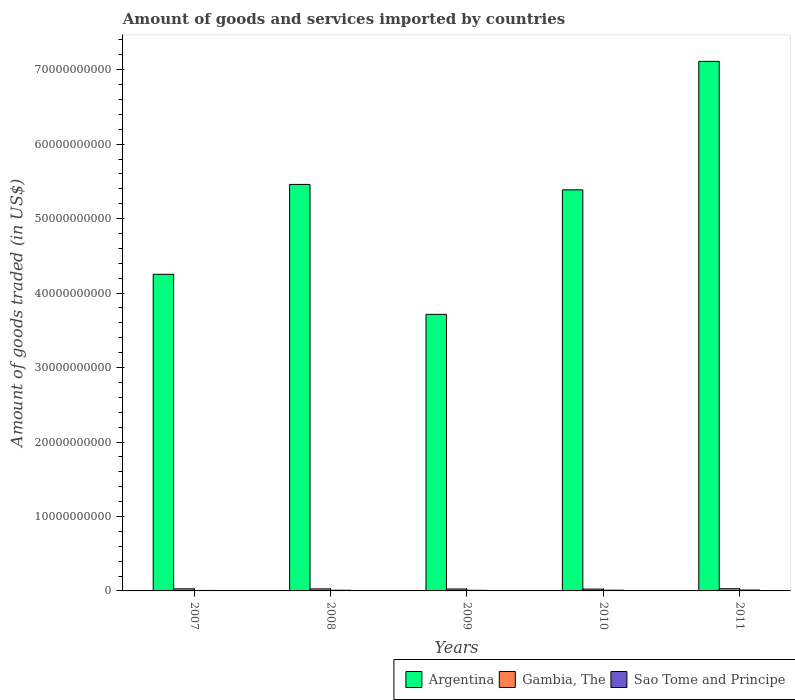How many groups of bars are there?
Your answer should be very brief. 5. How many bars are there on the 3rd tick from the right?
Your response must be concise. 3. What is the label of the 5th group of bars from the left?
Provide a short and direct response. 2011. In how many cases, is the number of bars for a given year not equal to the number of legend labels?
Ensure brevity in your answer.  0. What is the total amount of goods and services imported in Sao Tome and Principe in 2011?
Your answer should be very brief. 1.16e+08. Across all years, what is the maximum total amount of goods and services imported in Sao Tome and Principe?
Offer a terse response. 1.16e+08. Across all years, what is the minimum total amount of goods and services imported in Argentina?
Your answer should be compact. 3.71e+1. In which year was the total amount of goods and services imported in Argentina maximum?
Ensure brevity in your answer.  2011. What is the total total amount of goods and services imported in Sao Tome and Principe in the graph?
Offer a very short reply. 4.53e+08. What is the difference between the total amount of goods and services imported in Sao Tome and Principe in 2007 and that in 2009?
Make the answer very short. -1.89e+07. What is the difference between the total amount of goods and services imported in Gambia, The in 2008 and the total amount of goods and services imported in Argentina in 2007?
Offer a terse response. -4.22e+1. What is the average total amount of goods and services imported in Gambia, The per year?
Provide a succinct answer. 2.71e+08. In the year 2008, what is the difference between the total amount of goods and services imported in Argentina and total amount of goods and services imported in Gambia, The?
Your response must be concise. 5.43e+1. In how many years, is the total amount of goods and services imported in Argentina greater than 40000000000 US$?
Make the answer very short. 4. What is the ratio of the total amount of goods and services imported in Gambia, The in 2008 to that in 2009?
Make the answer very short. 1.06. Is the difference between the total amount of goods and services imported in Argentina in 2008 and 2010 greater than the difference between the total amount of goods and services imported in Gambia, The in 2008 and 2010?
Provide a succinct answer. Yes. What is the difference between the highest and the second highest total amount of goods and services imported in Gambia, The?
Ensure brevity in your answer.  1.60e+07. What is the difference between the highest and the lowest total amount of goods and services imported in Gambia, The?
Provide a short and direct response. 4.98e+07. What does the 2nd bar from the left in 2007 represents?
Offer a very short reply. Gambia, The. What does the 2nd bar from the right in 2008 represents?
Provide a succinct answer. Gambia, The. How many years are there in the graph?
Make the answer very short. 5. What is the difference between two consecutive major ticks on the Y-axis?
Give a very brief answer. 1.00e+1. Are the values on the major ticks of Y-axis written in scientific E-notation?
Give a very brief answer. No. Does the graph contain grids?
Make the answer very short. No. Where does the legend appear in the graph?
Offer a terse response. Bottom right. How many legend labels are there?
Your answer should be compact. 3. How are the legend labels stacked?
Offer a terse response. Horizontal. What is the title of the graph?
Make the answer very short. Amount of goods and services imported by countries. What is the label or title of the X-axis?
Your answer should be very brief. Years. What is the label or title of the Y-axis?
Your response must be concise. Amount of goods traded (in US$). What is the Amount of goods traded (in US$) in Argentina in 2007?
Make the answer very short. 4.25e+1. What is the Amount of goods traded (in US$) of Gambia, The in 2007?
Your response must be concise. 2.80e+08. What is the Amount of goods traded (in US$) of Sao Tome and Principe in 2007?
Your answer should be very brief. 6.49e+07. What is the Amount of goods traded (in US$) of Argentina in 2008?
Provide a short and direct response. 5.46e+1. What is the Amount of goods traded (in US$) in Gambia, The in 2008?
Provide a short and direct response. 2.75e+08. What is the Amount of goods traded (in US$) in Sao Tome and Principe in 2008?
Your response must be concise. 9.22e+07. What is the Amount of goods traded (in US$) in Argentina in 2009?
Offer a very short reply. 3.71e+1. What is the Amount of goods traded (in US$) of Gambia, The in 2009?
Provide a short and direct response. 2.60e+08. What is the Amount of goods traded (in US$) in Sao Tome and Principe in 2009?
Your answer should be compact. 8.38e+07. What is the Amount of goods traded (in US$) of Argentina in 2010?
Give a very brief answer. 5.39e+1. What is the Amount of goods traded (in US$) of Gambia, The in 2010?
Keep it short and to the point. 2.46e+08. What is the Amount of goods traded (in US$) of Sao Tome and Principe in 2010?
Ensure brevity in your answer.  9.62e+07. What is the Amount of goods traded (in US$) in Argentina in 2011?
Make the answer very short. 7.11e+1. What is the Amount of goods traded (in US$) of Gambia, The in 2011?
Offer a terse response. 2.96e+08. What is the Amount of goods traded (in US$) in Sao Tome and Principe in 2011?
Your answer should be very brief. 1.16e+08. Across all years, what is the maximum Amount of goods traded (in US$) of Argentina?
Provide a short and direct response. 7.11e+1. Across all years, what is the maximum Amount of goods traded (in US$) of Gambia, The?
Provide a succinct answer. 2.96e+08. Across all years, what is the maximum Amount of goods traded (in US$) of Sao Tome and Principe?
Provide a short and direct response. 1.16e+08. Across all years, what is the minimum Amount of goods traded (in US$) in Argentina?
Make the answer very short. 3.71e+1. Across all years, what is the minimum Amount of goods traded (in US$) in Gambia, The?
Offer a terse response. 2.46e+08. Across all years, what is the minimum Amount of goods traded (in US$) in Sao Tome and Principe?
Provide a short and direct response. 6.49e+07. What is the total Amount of goods traded (in US$) of Argentina in the graph?
Keep it short and to the point. 2.59e+11. What is the total Amount of goods traded (in US$) in Gambia, The in the graph?
Your response must be concise. 1.36e+09. What is the total Amount of goods traded (in US$) in Sao Tome and Principe in the graph?
Provide a succinct answer. 4.53e+08. What is the difference between the Amount of goods traded (in US$) of Argentina in 2007 and that in 2008?
Provide a succinct answer. -1.21e+1. What is the difference between the Amount of goods traded (in US$) of Gambia, The in 2007 and that in 2008?
Keep it short and to the point. 5.01e+06. What is the difference between the Amount of goods traded (in US$) in Sao Tome and Principe in 2007 and that in 2008?
Your answer should be very brief. -2.73e+07. What is the difference between the Amount of goods traded (in US$) in Argentina in 2007 and that in 2009?
Offer a terse response. 5.38e+09. What is the difference between the Amount of goods traded (in US$) in Gambia, The in 2007 and that in 2009?
Provide a succinct answer. 1.96e+07. What is the difference between the Amount of goods traded (in US$) of Sao Tome and Principe in 2007 and that in 2009?
Give a very brief answer. -1.89e+07. What is the difference between the Amount of goods traded (in US$) in Argentina in 2007 and that in 2010?
Keep it short and to the point. -1.13e+1. What is the difference between the Amount of goods traded (in US$) of Gambia, The in 2007 and that in 2010?
Provide a short and direct response. 3.38e+07. What is the difference between the Amount of goods traded (in US$) in Sao Tome and Principe in 2007 and that in 2010?
Your answer should be very brief. -3.13e+07. What is the difference between the Amount of goods traded (in US$) in Argentina in 2007 and that in 2011?
Provide a short and direct response. -2.86e+1. What is the difference between the Amount of goods traded (in US$) in Gambia, The in 2007 and that in 2011?
Your answer should be compact. -1.60e+07. What is the difference between the Amount of goods traded (in US$) of Sao Tome and Principe in 2007 and that in 2011?
Your answer should be very brief. -5.08e+07. What is the difference between the Amount of goods traded (in US$) of Argentina in 2008 and that in 2009?
Your answer should be compact. 1.75e+1. What is the difference between the Amount of goods traded (in US$) of Gambia, The in 2008 and that in 2009?
Ensure brevity in your answer.  1.46e+07. What is the difference between the Amount of goods traded (in US$) in Sao Tome and Principe in 2008 and that in 2009?
Keep it short and to the point. 8.39e+06. What is the difference between the Amount of goods traded (in US$) in Argentina in 2008 and that in 2010?
Offer a terse response. 7.28e+08. What is the difference between the Amount of goods traded (in US$) of Gambia, The in 2008 and that in 2010?
Keep it short and to the point. 2.88e+07. What is the difference between the Amount of goods traded (in US$) of Sao Tome and Principe in 2008 and that in 2010?
Your answer should be very brief. -4.04e+06. What is the difference between the Amount of goods traded (in US$) in Argentina in 2008 and that in 2011?
Make the answer very short. -1.65e+1. What is the difference between the Amount of goods traded (in US$) in Gambia, The in 2008 and that in 2011?
Ensure brevity in your answer.  -2.10e+07. What is the difference between the Amount of goods traded (in US$) of Sao Tome and Principe in 2008 and that in 2011?
Make the answer very short. -2.35e+07. What is the difference between the Amount of goods traded (in US$) in Argentina in 2009 and that in 2010?
Give a very brief answer. -1.67e+1. What is the difference between the Amount of goods traded (in US$) in Gambia, The in 2009 and that in 2010?
Your answer should be compact. 1.42e+07. What is the difference between the Amount of goods traded (in US$) in Sao Tome and Principe in 2009 and that in 2010?
Your answer should be compact. -1.24e+07. What is the difference between the Amount of goods traded (in US$) in Argentina in 2009 and that in 2011?
Your response must be concise. -3.40e+1. What is the difference between the Amount of goods traded (in US$) in Gambia, The in 2009 and that in 2011?
Make the answer very short. -3.56e+07. What is the difference between the Amount of goods traded (in US$) of Sao Tome and Principe in 2009 and that in 2011?
Your answer should be very brief. -3.19e+07. What is the difference between the Amount of goods traded (in US$) in Argentina in 2010 and that in 2011?
Make the answer very short. -1.73e+1. What is the difference between the Amount of goods traded (in US$) of Gambia, The in 2010 and that in 2011?
Give a very brief answer. -4.98e+07. What is the difference between the Amount of goods traded (in US$) in Sao Tome and Principe in 2010 and that in 2011?
Your answer should be compact. -1.95e+07. What is the difference between the Amount of goods traded (in US$) of Argentina in 2007 and the Amount of goods traded (in US$) of Gambia, The in 2008?
Offer a very short reply. 4.22e+1. What is the difference between the Amount of goods traded (in US$) of Argentina in 2007 and the Amount of goods traded (in US$) of Sao Tome and Principe in 2008?
Keep it short and to the point. 4.24e+1. What is the difference between the Amount of goods traded (in US$) in Gambia, The in 2007 and the Amount of goods traded (in US$) in Sao Tome and Principe in 2008?
Your answer should be very brief. 1.87e+08. What is the difference between the Amount of goods traded (in US$) in Argentina in 2007 and the Amount of goods traded (in US$) in Gambia, The in 2009?
Offer a terse response. 4.23e+1. What is the difference between the Amount of goods traded (in US$) of Argentina in 2007 and the Amount of goods traded (in US$) of Sao Tome and Principe in 2009?
Your answer should be very brief. 4.24e+1. What is the difference between the Amount of goods traded (in US$) of Gambia, The in 2007 and the Amount of goods traded (in US$) of Sao Tome and Principe in 2009?
Ensure brevity in your answer.  1.96e+08. What is the difference between the Amount of goods traded (in US$) of Argentina in 2007 and the Amount of goods traded (in US$) of Gambia, The in 2010?
Keep it short and to the point. 4.23e+1. What is the difference between the Amount of goods traded (in US$) of Argentina in 2007 and the Amount of goods traded (in US$) of Sao Tome and Principe in 2010?
Provide a short and direct response. 4.24e+1. What is the difference between the Amount of goods traded (in US$) in Gambia, The in 2007 and the Amount of goods traded (in US$) in Sao Tome and Principe in 2010?
Provide a short and direct response. 1.83e+08. What is the difference between the Amount of goods traded (in US$) of Argentina in 2007 and the Amount of goods traded (in US$) of Gambia, The in 2011?
Offer a terse response. 4.22e+1. What is the difference between the Amount of goods traded (in US$) of Argentina in 2007 and the Amount of goods traded (in US$) of Sao Tome and Principe in 2011?
Offer a very short reply. 4.24e+1. What is the difference between the Amount of goods traded (in US$) in Gambia, The in 2007 and the Amount of goods traded (in US$) in Sao Tome and Principe in 2011?
Make the answer very short. 1.64e+08. What is the difference between the Amount of goods traded (in US$) of Argentina in 2008 and the Amount of goods traded (in US$) of Gambia, The in 2009?
Offer a terse response. 5.43e+1. What is the difference between the Amount of goods traded (in US$) in Argentina in 2008 and the Amount of goods traded (in US$) in Sao Tome and Principe in 2009?
Offer a very short reply. 5.45e+1. What is the difference between the Amount of goods traded (in US$) in Gambia, The in 2008 and the Amount of goods traded (in US$) in Sao Tome and Principe in 2009?
Provide a short and direct response. 1.91e+08. What is the difference between the Amount of goods traded (in US$) of Argentina in 2008 and the Amount of goods traded (in US$) of Gambia, The in 2010?
Offer a terse response. 5.44e+1. What is the difference between the Amount of goods traded (in US$) in Argentina in 2008 and the Amount of goods traded (in US$) in Sao Tome and Principe in 2010?
Your answer should be compact. 5.45e+1. What is the difference between the Amount of goods traded (in US$) in Gambia, The in 2008 and the Amount of goods traded (in US$) in Sao Tome and Principe in 2010?
Provide a succinct answer. 1.78e+08. What is the difference between the Amount of goods traded (in US$) in Argentina in 2008 and the Amount of goods traded (in US$) in Gambia, The in 2011?
Make the answer very short. 5.43e+1. What is the difference between the Amount of goods traded (in US$) of Argentina in 2008 and the Amount of goods traded (in US$) of Sao Tome and Principe in 2011?
Make the answer very short. 5.45e+1. What is the difference between the Amount of goods traded (in US$) of Gambia, The in 2008 and the Amount of goods traded (in US$) of Sao Tome and Principe in 2011?
Provide a short and direct response. 1.59e+08. What is the difference between the Amount of goods traded (in US$) of Argentina in 2009 and the Amount of goods traded (in US$) of Gambia, The in 2010?
Your response must be concise. 3.69e+1. What is the difference between the Amount of goods traded (in US$) of Argentina in 2009 and the Amount of goods traded (in US$) of Sao Tome and Principe in 2010?
Provide a succinct answer. 3.70e+1. What is the difference between the Amount of goods traded (in US$) of Gambia, The in 2009 and the Amount of goods traded (in US$) of Sao Tome and Principe in 2010?
Keep it short and to the point. 1.64e+08. What is the difference between the Amount of goods traded (in US$) of Argentina in 2009 and the Amount of goods traded (in US$) of Gambia, The in 2011?
Offer a very short reply. 3.69e+1. What is the difference between the Amount of goods traded (in US$) in Argentina in 2009 and the Amount of goods traded (in US$) in Sao Tome and Principe in 2011?
Offer a very short reply. 3.70e+1. What is the difference between the Amount of goods traded (in US$) of Gambia, The in 2009 and the Amount of goods traded (in US$) of Sao Tome and Principe in 2011?
Provide a succinct answer. 1.44e+08. What is the difference between the Amount of goods traded (in US$) in Argentina in 2010 and the Amount of goods traded (in US$) in Gambia, The in 2011?
Your answer should be very brief. 5.36e+1. What is the difference between the Amount of goods traded (in US$) in Argentina in 2010 and the Amount of goods traded (in US$) in Sao Tome and Principe in 2011?
Offer a very short reply. 5.38e+1. What is the difference between the Amount of goods traded (in US$) of Gambia, The in 2010 and the Amount of goods traded (in US$) of Sao Tome and Principe in 2011?
Provide a short and direct response. 1.30e+08. What is the average Amount of goods traded (in US$) of Argentina per year?
Provide a succinct answer. 5.19e+1. What is the average Amount of goods traded (in US$) of Gambia, The per year?
Provide a succinct answer. 2.71e+08. What is the average Amount of goods traded (in US$) in Sao Tome and Principe per year?
Ensure brevity in your answer.  9.05e+07. In the year 2007, what is the difference between the Amount of goods traded (in US$) in Argentina and Amount of goods traded (in US$) in Gambia, The?
Offer a very short reply. 4.22e+1. In the year 2007, what is the difference between the Amount of goods traded (in US$) in Argentina and Amount of goods traded (in US$) in Sao Tome and Principe?
Ensure brevity in your answer.  4.25e+1. In the year 2007, what is the difference between the Amount of goods traded (in US$) of Gambia, The and Amount of goods traded (in US$) of Sao Tome and Principe?
Provide a short and direct response. 2.15e+08. In the year 2008, what is the difference between the Amount of goods traded (in US$) in Argentina and Amount of goods traded (in US$) in Gambia, The?
Your response must be concise. 5.43e+1. In the year 2008, what is the difference between the Amount of goods traded (in US$) of Argentina and Amount of goods traded (in US$) of Sao Tome and Principe?
Your answer should be compact. 5.45e+1. In the year 2008, what is the difference between the Amount of goods traded (in US$) in Gambia, The and Amount of goods traded (in US$) in Sao Tome and Principe?
Your answer should be very brief. 1.82e+08. In the year 2009, what is the difference between the Amount of goods traded (in US$) of Argentina and Amount of goods traded (in US$) of Gambia, The?
Offer a very short reply. 3.69e+1. In the year 2009, what is the difference between the Amount of goods traded (in US$) of Argentina and Amount of goods traded (in US$) of Sao Tome and Principe?
Your answer should be very brief. 3.71e+1. In the year 2009, what is the difference between the Amount of goods traded (in US$) of Gambia, The and Amount of goods traded (in US$) of Sao Tome and Principe?
Your answer should be compact. 1.76e+08. In the year 2010, what is the difference between the Amount of goods traded (in US$) in Argentina and Amount of goods traded (in US$) in Gambia, The?
Keep it short and to the point. 5.36e+1. In the year 2010, what is the difference between the Amount of goods traded (in US$) in Argentina and Amount of goods traded (in US$) in Sao Tome and Principe?
Provide a succinct answer. 5.38e+1. In the year 2010, what is the difference between the Amount of goods traded (in US$) in Gambia, The and Amount of goods traded (in US$) in Sao Tome and Principe?
Ensure brevity in your answer.  1.50e+08. In the year 2011, what is the difference between the Amount of goods traded (in US$) of Argentina and Amount of goods traded (in US$) of Gambia, The?
Give a very brief answer. 7.08e+1. In the year 2011, what is the difference between the Amount of goods traded (in US$) of Argentina and Amount of goods traded (in US$) of Sao Tome and Principe?
Keep it short and to the point. 7.10e+1. In the year 2011, what is the difference between the Amount of goods traded (in US$) of Gambia, The and Amount of goods traded (in US$) of Sao Tome and Principe?
Your response must be concise. 1.80e+08. What is the ratio of the Amount of goods traded (in US$) in Argentina in 2007 to that in 2008?
Keep it short and to the point. 0.78. What is the ratio of the Amount of goods traded (in US$) of Gambia, The in 2007 to that in 2008?
Provide a short and direct response. 1.02. What is the ratio of the Amount of goods traded (in US$) of Sao Tome and Principe in 2007 to that in 2008?
Provide a short and direct response. 0.7. What is the ratio of the Amount of goods traded (in US$) of Argentina in 2007 to that in 2009?
Your response must be concise. 1.14. What is the ratio of the Amount of goods traded (in US$) of Gambia, The in 2007 to that in 2009?
Give a very brief answer. 1.08. What is the ratio of the Amount of goods traded (in US$) in Sao Tome and Principe in 2007 to that in 2009?
Your answer should be compact. 0.77. What is the ratio of the Amount of goods traded (in US$) in Argentina in 2007 to that in 2010?
Your response must be concise. 0.79. What is the ratio of the Amount of goods traded (in US$) in Gambia, The in 2007 to that in 2010?
Your response must be concise. 1.14. What is the ratio of the Amount of goods traded (in US$) in Sao Tome and Principe in 2007 to that in 2010?
Give a very brief answer. 0.67. What is the ratio of the Amount of goods traded (in US$) in Argentina in 2007 to that in 2011?
Keep it short and to the point. 0.6. What is the ratio of the Amount of goods traded (in US$) in Gambia, The in 2007 to that in 2011?
Provide a short and direct response. 0.95. What is the ratio of the Amount of goods traded (in US$) in Sao Tome and Principe in 2007 to that in 2011?
Ensure brevity in your answer.  0.56. What is the ratio of the Amount of goods traded (in US$) in Argentina in 2008 to that in 2009?
Provide a short and direct response. 1.47. What is the ratio of the Amount of goods traded (in US$) of Gambia, The in 2008 to that in 2009?
Offer a terse response. 1.06. What is the ratio of the Amount of goods traded (in US$) in Sao Tome and Principe in 2008 to that in 2009?
Provide a succinct answer. 1.1. What is the ratio of the Amount of goods traded (in US$) in Argentina in 2008 to that in 2010?
Your answer should be compact. 1.01. What is the ratio of the Amount of goods traded (in US$) in Gambia, The in 2008 to that in 2010?
Keep it short and to the point. 1.12. What is the ratio of the Amount of goods traded (in US$) of Sao Tome and Principe in 2008 to that in 2010?
Your answer should be compact. 0.96. What is the ratio of the Amount of goods traded (in US$) of Argentina in 2008 to that in 2011?
Your answer should be very brief. 0.77. What is the ratio of the Amount of goods traded (in US$) of Gambia, The in 2008 to that in 2011?
Your response must be concise. 0.93. What is the ratio of the Amount of goods traded (in US$) of Sao Tome and Principe in 2008 to that in 2011?
Your answer should be very brief. 0.8. What is the ratio of the Amount of goods traded (in US$) of Argentina in 2009 to that in 2010?
Offer a terse response. 0.69. What is the ratio of the Amount of goods traded (in US$) of Gambia, The in 2009 to that in 2010?
Your answer should be very brief. 1.06. What is the ratio of the Amount of goods traded (in US$) of Sao Tome and Principe in 2009 to that in 2010?
Offer a very short reply. 0.87. What is the ratio of the Amount of goods traded (in US$) of Argentina in 2009 to that in 2011?
Offer a terse response. 0.52. What is the ratio of the Amount of goods traded (in US$) in Gambia, The in 2009 to that in 2011?
Make the answer very short. 0.88. What is the ratio of the Amount of goods traded (in US$) in Sao Tome and Principe in 2009 to that in 2011?
Your answer should be very brief. 0.72. What is the ratio of the Amount of goods traded (in US$) in Argentina in 2010 to that in 2011?
Give a very brief answer. 0.76. What is the ratio of the Amount of goods traded (in US$) in Gambia, The in 2010 to that in 2011?
Provide a short and direct response. 0.83. What is the ratio of the Amount of goods traded (in US$) of Sao Tome and Principe in 2010 to that in 2011?
Your answer should be very brief. 0.83. What is the difference between the highest and the second highest Amount of goods traded (in US$) in Argentina?
Keep it short and to the point. 1.65e+1. What is the difference between the highest and the second highest Amount of goods traded (in US$) of Gambia, The?
Provide a short and direct response. 1.60e+07. What is the difference between the highest and the second highest Amount of goods traded (in US$) in Sao Tome and Principe?
Make the answer very short. 1.95e+07. What is the difference between the highest and the lowest Amount of goods traded (in US$) of Argentina?
Your answer should be very brief. 3.40e+1. What is the difference between the highest and the lowest Amount of goods traded (in US$) of Gambia, The?
Keep it short and to the point. 4.98e+07. What is the difference between the highest and the lowest Amount of goods traded (in US$) in Sao Tome and Principe?
Your response must be concise. 5.08e+07. 